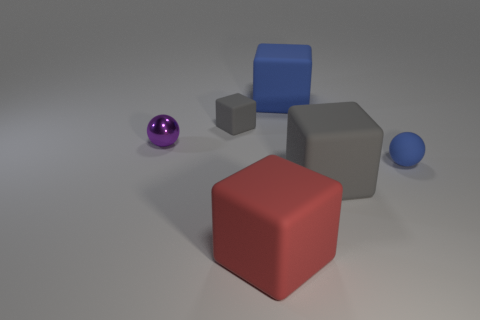Are there any other things that are made of the same material as the purple sphere?
Give a very brief answer. No. There is another gray object that is made of the same material as the small gray object; what size is it?
Your answer should be very brief. Large. The ball that is to the right of the gray rubber thing behind the small matte sphere is what color?
Offer a terse response. Blue. How many tiny blue spheres are made of the same material as the blue cube?
Offer a terse response. 1. What number of metal things are red spheres or large objects?
Make the answer very short. 0. There is a cube that is the same size as the purple metallic ball; what is its material?
Your response must be concise. Rubber. Are there any small blue balls that have the same material as the purple object?
Provide a succinct answer. No. There is a large thing to the left of the big matte thing behind the gray matte object behind the metallic ball; what is its shape?
Offer a very short reply. Cube. There is a red object; does it have the same size as the blue object that is in front of the purple ball?
Keep it short and to the point. No. There is a rubber object that is in front of the blue rubber ball and on the right side of the red rubber block; what shape is it?
Provide a short and direct response. Cube. 